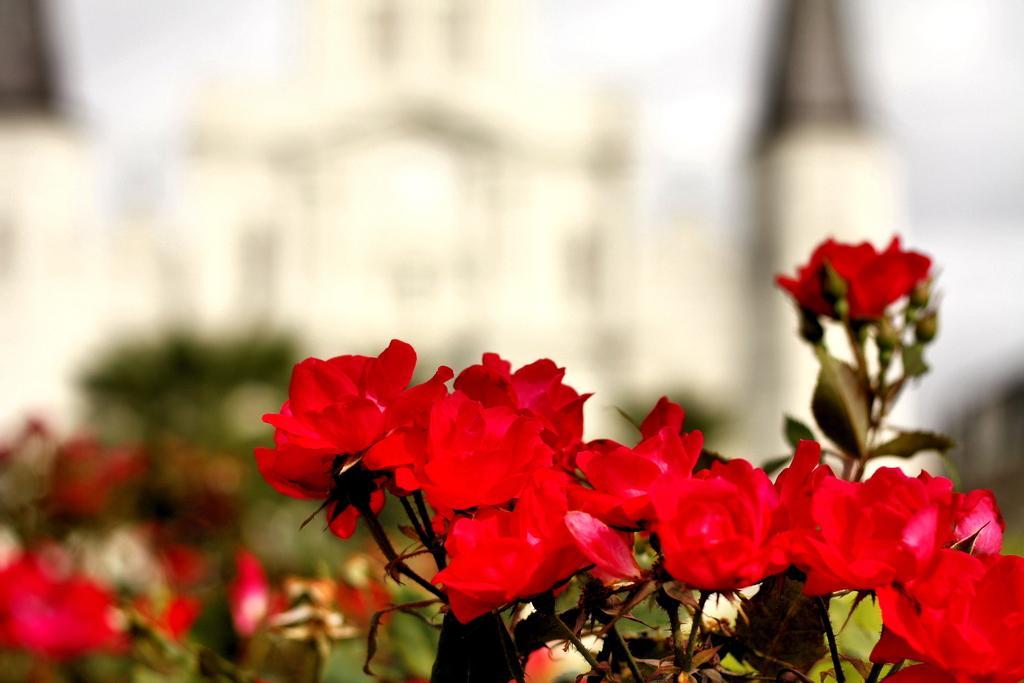Could you give a brief overview of what you see in this image? At the bottom of this image, there are plants having red color flowers. And the background is blurred. 